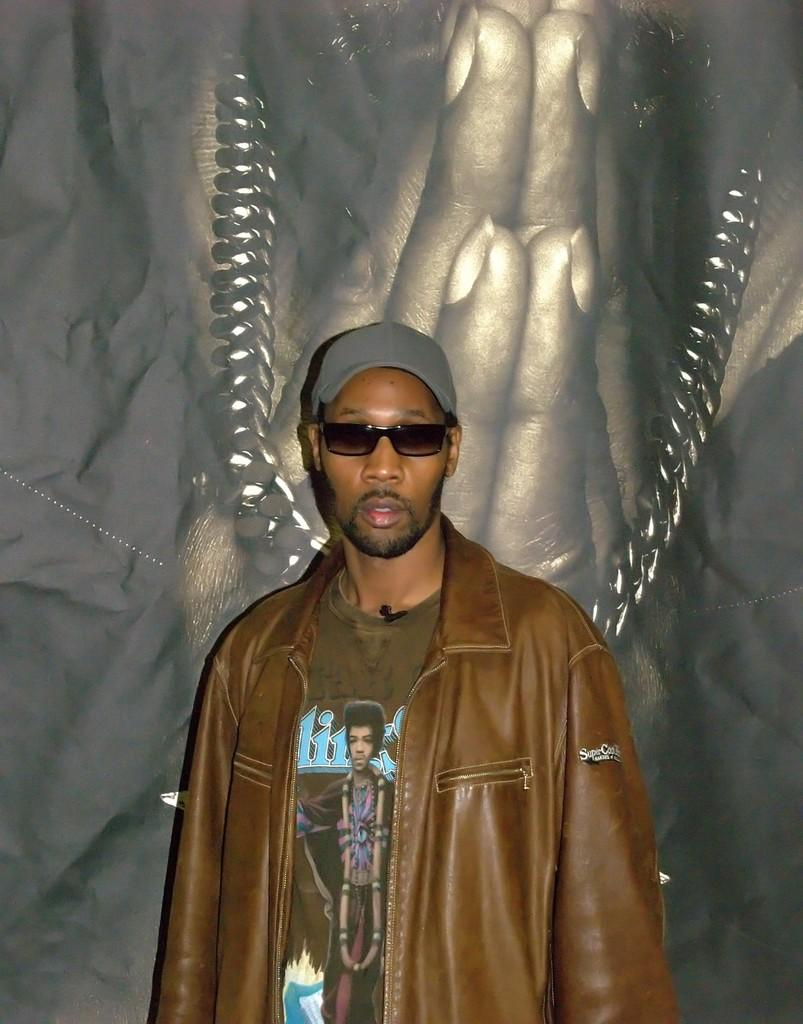What is the main subject of the image? There is a person in the image. What is the person wearing on their upper body? The person is wearing a brown color jacket. What protective gear is the person wearing? The person is wearing goggles. What type of headwear is the person wearing? The person is wearing a cap. What can be seen in the background of the image? There are persons' hands and a chain visible in the background of the image. Can you tell me how many times the person sneezes in the image? There is no indication of the person sneezing in the image. What type of coast can be seen in the background of the image? There is no coast visible in the image; it is focused on the person and the background elements mentioned in the facts. 